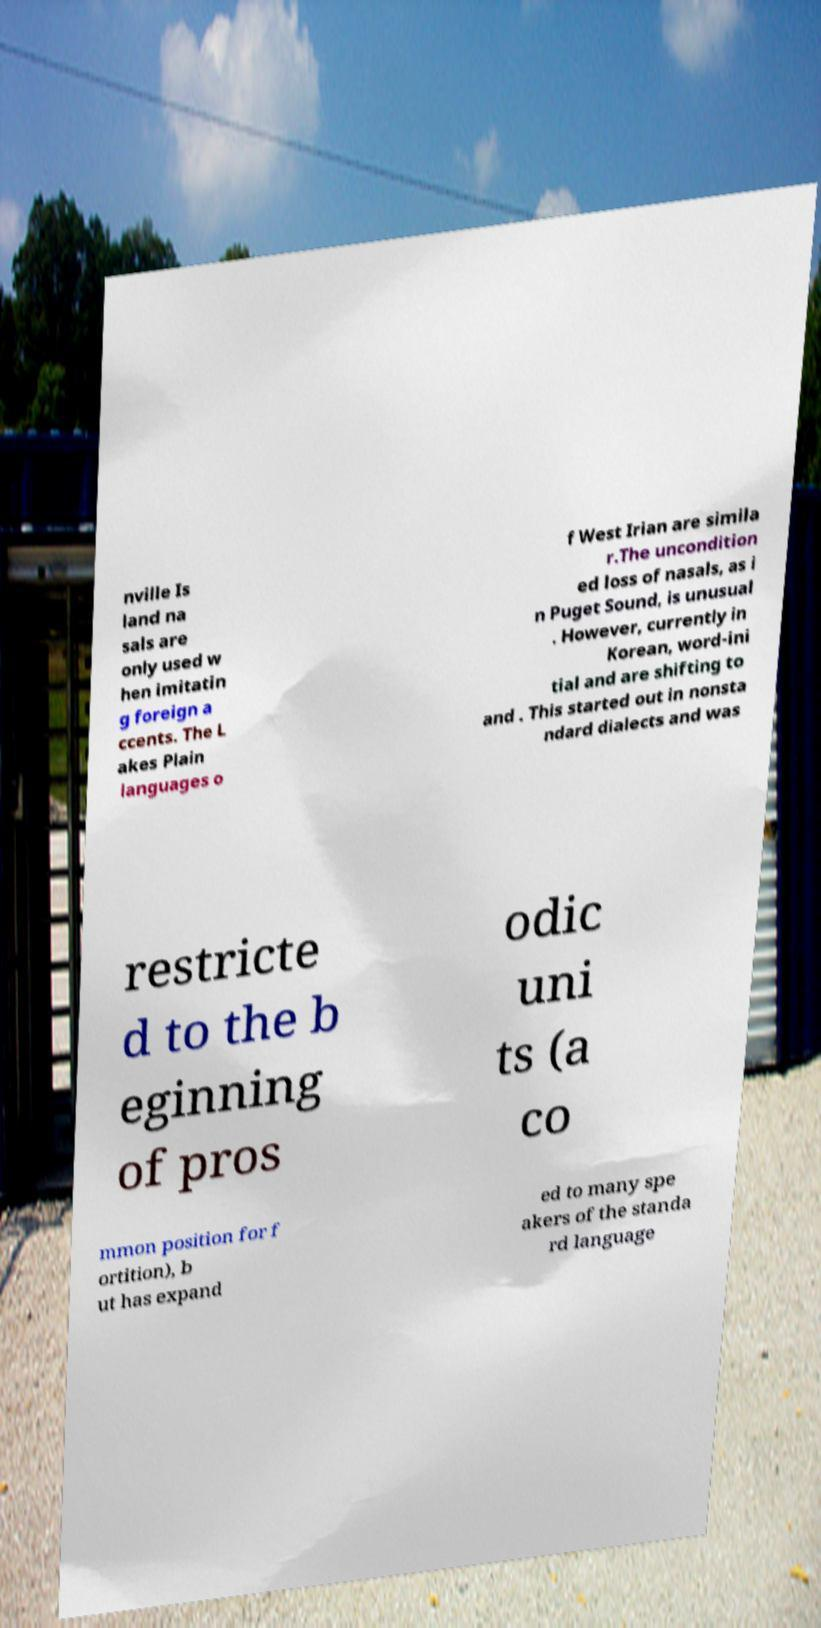What messages or text are displayed in this image? I need them in a readable, typed format. nville Is land na sals are only used w hen imitatin g foreign a ccents. The L akes Plain languages o f West Irian are simila r.The uncondition ed loss of nasals, as i n Puget Sound, is unusual . However, currently in Korean, word-ini tial and are shifting to and . This started out in nonsta ndard dialects and was restricte d to the b eginning of pros odic uni ts (a co mmon position for f ortition), b ut has expand ed to many spe akers of the standa rd language 